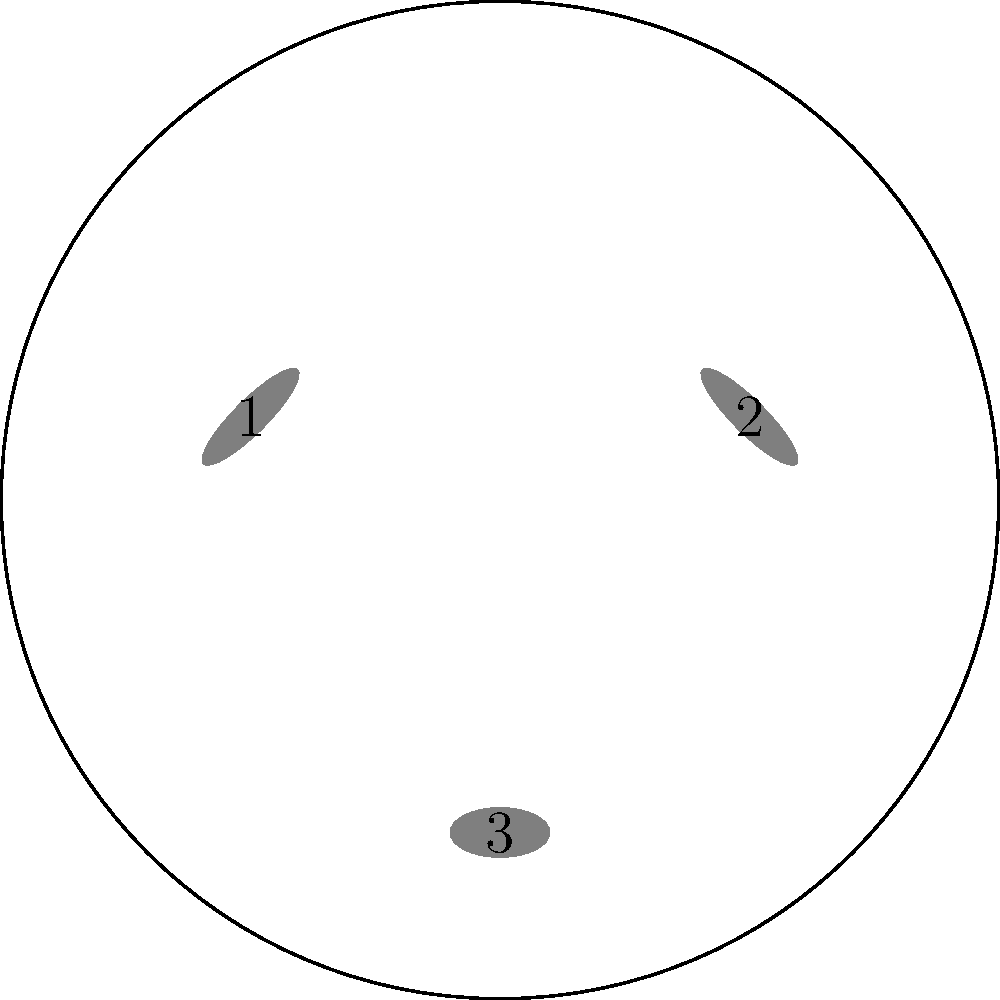You're designing a logo for your cookbook that features a plate with utensils. The image shows a circular plate with three utensils labeled 1, 2, and 3. To create a unique, trademarkable design, you need to rotate the entire arrangement. If you rotate the current arrangement 120° clockwise, which utensil will end up in the position currently occupied by utensil 1? To solve this problem, we need to visualize the rotation of the entire arrangement:

1. The current arrangement has utensil 1 (fork) at the top left, utensil 2 (knife) at the top right, and utensil 3 (spoon) at the bottom.

2. A 120° clockwise rotation is equivalent to rotating the arrangement by one-third of a full circle.

3. After a 120° clockwise rotation:
   - The position currently occupied by utensil 1 will be taken by the utensil that was at the bottom.
   - The utensil at the bottom will move to the top right.
   - The utensil at the top right will move to the top left.

4. Therefore, utensil 3 (the spoon), which was originally at the bottom, will end up in the position currently occupied by utensil 1.

This spatial reasoning is crucial for creating unique designs that can be trademarked, as it demonstrates the ability to mentally manipulate and transform visual elements.
Answer: 3 